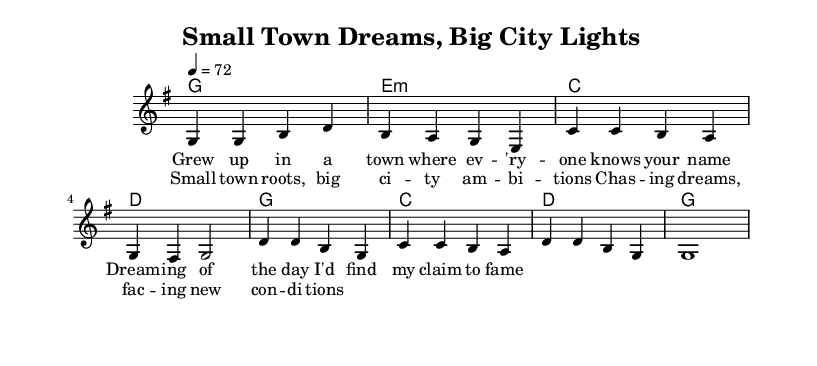What is the key signature of this music? The key signature is G major, which has one sharp (F#). This is indicated at the beginning of the staff.
Answer: G major What is the time signature of this sheet music? The time signature is 4/4, meaning there are four beats in each measure and a quarter note receives one beat. This is noted at the beginning of the score.
Answer: 4/4 What is the tempo marking for this piece? The piece is marked at a tempo of 72 beats per minute, written as "4 = 72". This indicates the speed at which the music should be played.
Answer: 72 How many measures are in the verse? The verse consists of four measures, as identified by counting the bars in the section labeled as "Verse".
Answer: Four What is the first lyric of the chorus? The first lyric of the chorus is "Small town roots," which is shown beneath the corresponding melody notes in the sheet music.
Answer: Small town roots How many different chords are used in the verse? The verse uses four different chords, indicated by the chord symbols above the notes. The chords are G, E minor, C, and D, each representing a different harmony.
Answer: Four What do the lyrics "Chasing dreams, facing new conditions" relate to in the context of country music themes? These lyrics reflect the common country music themes of aspiration and the contrast between humble beginnings and the pursuit of success in a larger world. They represent the narrative of striving for greater achievements.
Answer: Dreams 